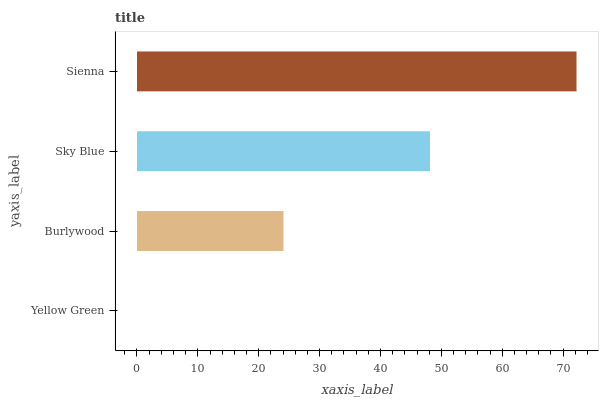Is Yellow Green the minimum?
Answer yes or no. Yes. Is Sienna the maximum?
Answer yes or no. Yes. Is Burlywood the minimum?
Answer yes or no. No. Is Burlywood the maximum?
Answer yes or no. No. Is Burlywood greater than Yellow Green?
Answer yes or no. Yes. Is Yellow Green less than Burlywood?
Answer yes or no. Yes. Is Yellow Green greater than Burlywood?
Answer yes or no. No. Is Burlywood less than Yellow Green?
Answer yes or no. No. Is Sky Blue the high median?
Answer yes or no. Yes. Is Burlywood the low median?
Answer yes or no. Yes. Is Yellow Green the high median?
Answer yes or no. No. Is Yellow Green the low median?
Answer yes or no. No. 